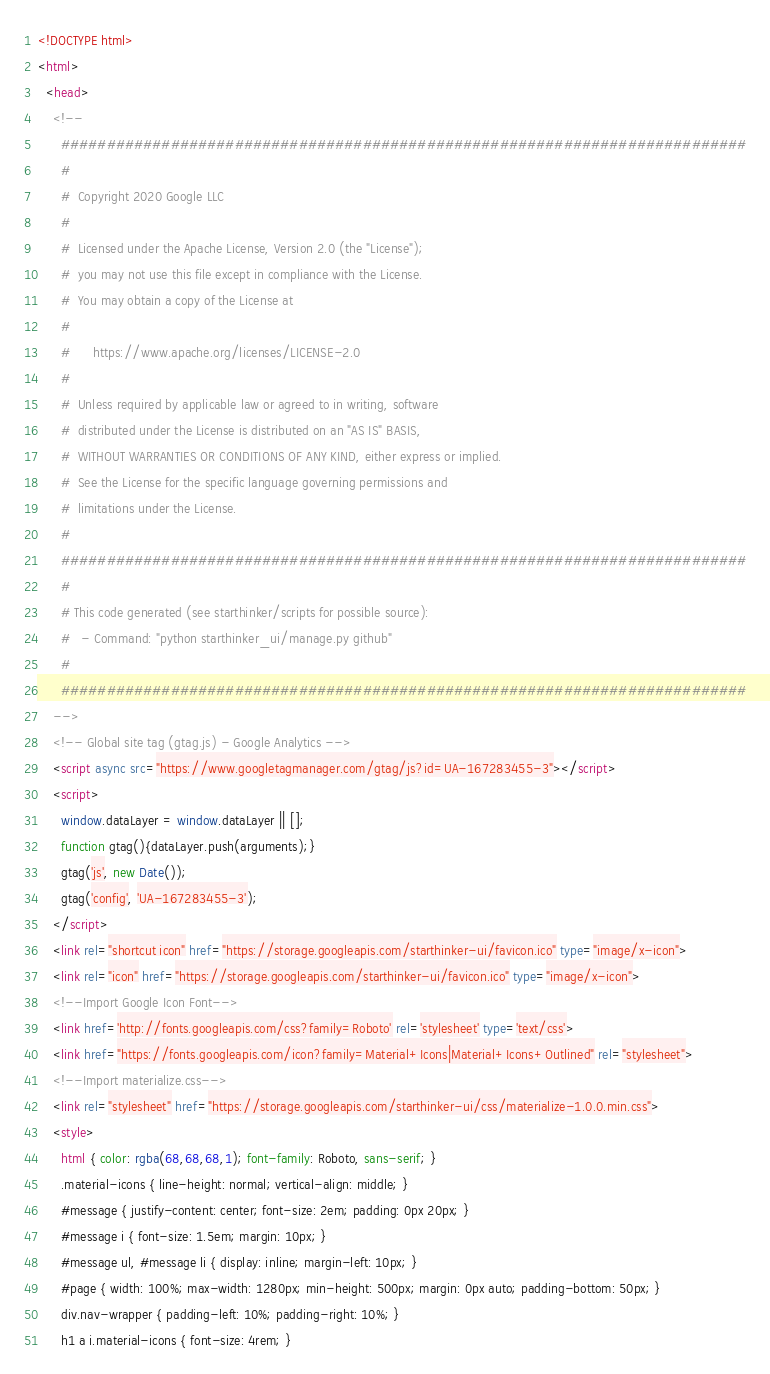Convert code to text. <code><loc_0><loc_0><loc_500><loc_500><_HTML_>
<!DOCTYPE html>
<html>
  <head>
    <!--
      ###########################################################################
      #
      #  Copyright 2020 Google LLC
      #
      #  Licensed under the Apache License, Version 2.0 (the "License");
      #  you may not use this file except in compliance with the License.
      #  You may obtain a copy of the License at
      #
      #      https://www.apache.org/licenses/LICENSE-2.0
      #
      #  Unless required by applicable law or agreed to in writing, software
      #  distributed under the License is distributed on an "AS IS" BASIS,
      #  WITHOUT WARRANTIES OR CONDITIONS OF ANY KIND, either express or implied.
      #  See the License for the specific language governing permissions and
      #  limitations under the License.
      #
      ###########################################################################
      #
      # This code generated (see starthinker/scripts for possible source):
      #   - Command: "python starthinker_ui/manage.py github"
      #
      ###########################################################################
    -->
    <!-- Global site tag (gtag.js) - Google Analytics -->
    <script async src="https://www.googletagmanager.com/gtag/js?id=UA-167283455-3"></script>
    <script>
      window.dataLayer = window.dataLayer || [];
      function gtag(){dataLayer.push(arguments);}
      gtag('js', new Date());
      gtag('config', 'UA-167283455-3');
    </script>
    <link rel="shortcut icon" href="https://storage.googleapis.com/starthinker-ui/favicon.ico" type="image/x-icon">
    <link rel="icon" href="https://storage.googleapis.com/starthinker-ui/favicon.ico" type="image/x-icon">
    <!--Import Google Icon Font-->
    <link href='http://fonts.googleapis.com/css?family=Roboto' rel='stylesheet' type='text/css'>
    <link href="https://fonts.googleapis.com/icon?family=Material+Icons|Material+Icons+Outlined" rel="stylesheet">
    <!--Import materialize.css-->
    <link rel="stylesheet" href="https://storage.googleapis.com/starthinker-ui/css/materialize-1.0.0.min.css">
    <style>
      html { color: rgba(68,68,68,1); font-family: Roboto, sans-serif; }
      .material-icons { line-height: normal; vertical-align: middle; }
      #message { justify-content: center; font-size: 2em; padding: 0px 20px; }
      #message i { font-size: 1.5em; margin: 10px; }
      #message ul, #message li { display: inline; margin-left: 10px; }
      #page { width: 100%; max-width: 1280px; min-height: 500px; margin: 0px auto; padding-bottom: 50px; }
      div.nav-wrapper { padding-left: 10%; padding-right: 10%; }
      h1 a i.material-icons { font-size: 4rem; }</code> 